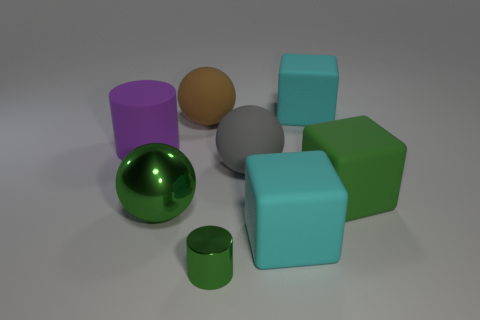Add 1 purple matte things. How many objects exist? 9 Subtract all cylinders. How many objects are left? 6 Add 3 small objects. How many small objects are left? 4 Add 2 big cyan objects. How many big cyan objects exist? 4 Subtract 0 cyan balls. How many objects are left? 8 Subtract all green metal things. Subtract all small cylinders. How many objects are left? 5 